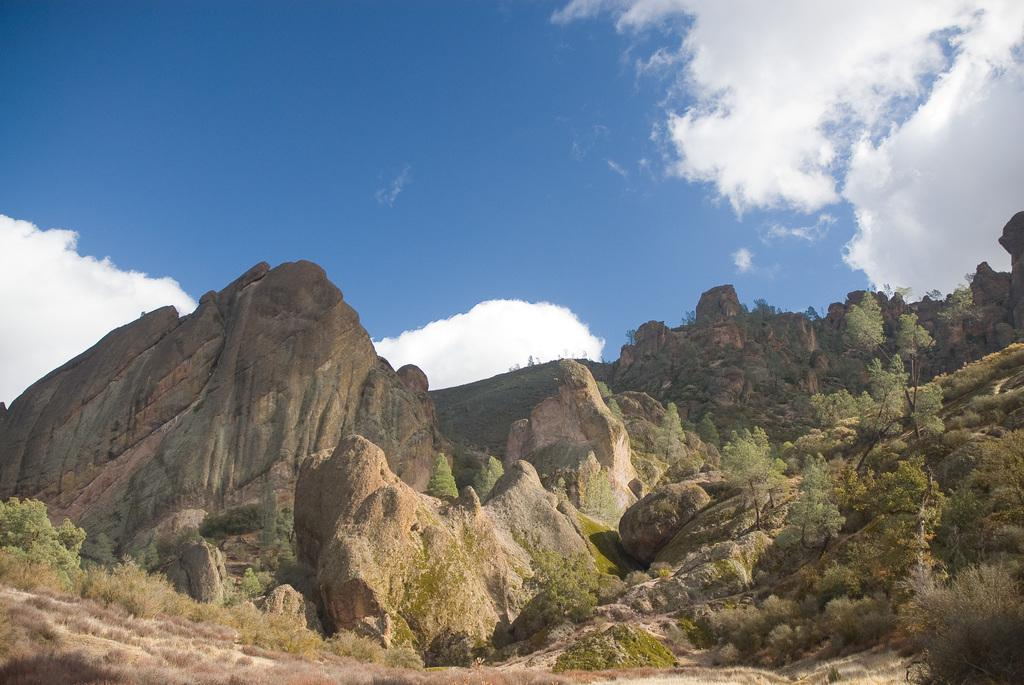What type of landscape is depicted in the image? The image features hills and trees. What can be seen in the sky in the image? There are clouds in the sky in the image. What is visible in the background of the image? The sky is visible in the background of the image. What type of whistle can be heard in the image? There is no whistle present in the image, as it is a still image and does not contain any sounds. 